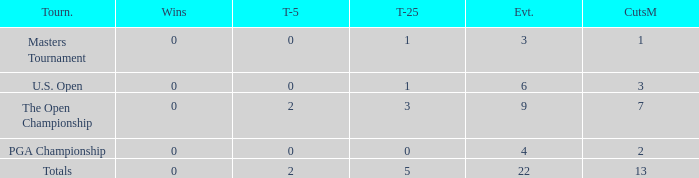What is the average number of cuts made for events with 0 top-5s? None. 